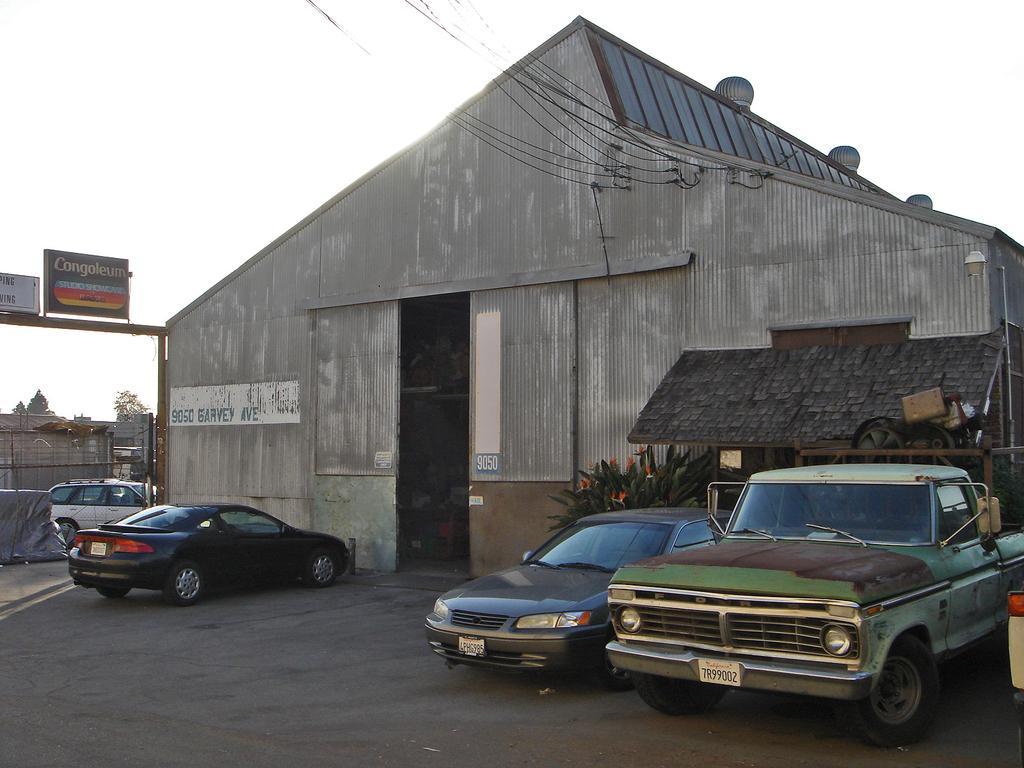Describe this image in one or two sentences. In the image I can see a shed like thing and around there are some cars, trees and some boards. 